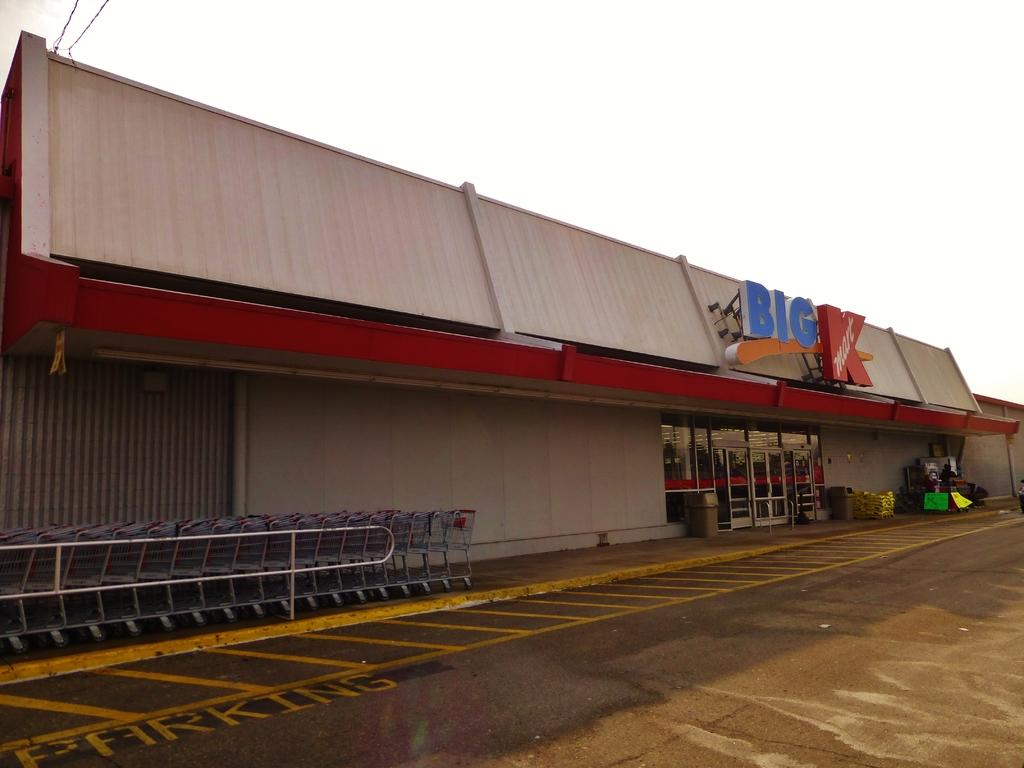What type of establishment is depicted in the image? There is a store in the image. What is unique about the store's construction? The store has glass doors and walls. What are some items or tools used for shopping in the image? There are carts in the image. What are the rods used for in the image? The rods are likely used for hanging or displaying items in the store. What are the dustbins used for in the image? The dustbins are used for disposing of waste or trash in the store. Can you describe any other objects present in the image? There are other objects in the image, but their specific purpose is not clear from the provided facts. What is visible at the bottom of the image? There is a road at the bottom of the image. What can be seen in the background of the image? The sky is visible in the background of the image. What time of day is it in the image, and how does society influence the store's operations? The provided facts do not mention the time of day or any societal influences on the store's operations. 